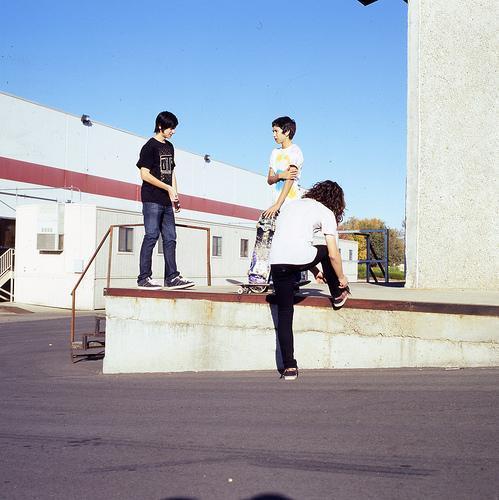How many people are shown?
Give a very brief answer. 3. How many red stripes run along the building on the left?
Give a very brief answer. 1. 